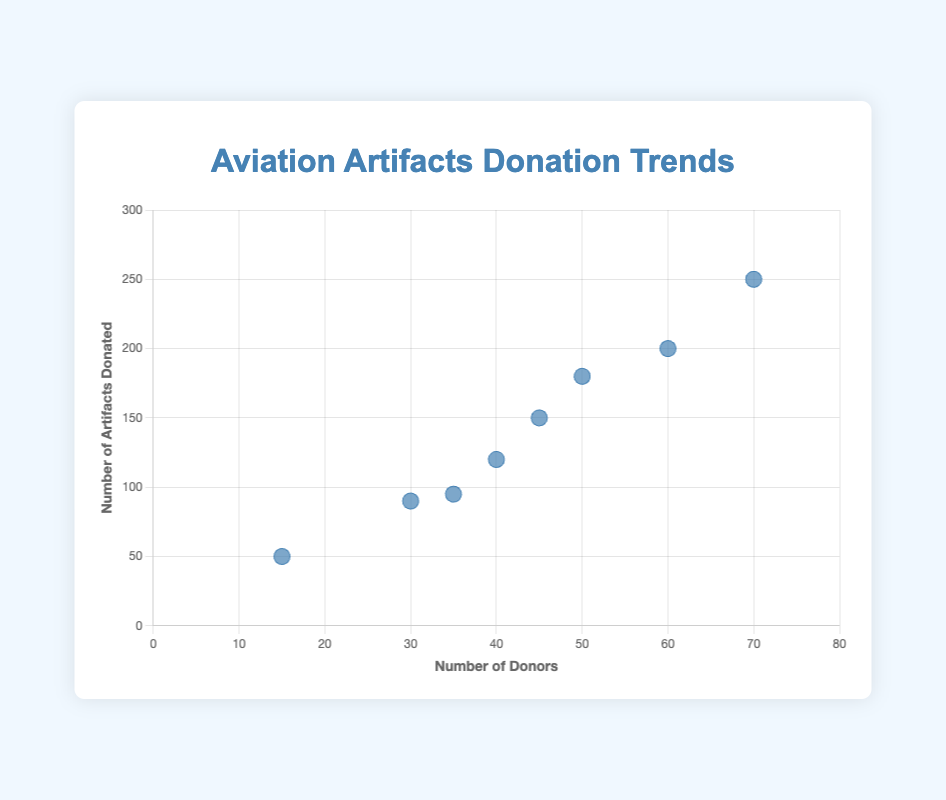How many data points are shown on the scatter plot? The scatter plot represents data for each decade, and there are 8 different decades shown on the plot.
Answer: 8 Which decade has the highest number of aviation artifacts donated? By looking at the y-axis, the 2010s decade has the highest y-value of 250 artifacts donated.
Answer: 2010s Is there a decade where the number of donors exceeds 60? Referring to the x-axis, the 2010s decade is the only one where the number of donors reaches 70, which is greater than 60.
Answer: Yes What is the average number of donors across all decades? Sum all the donors (15+30+40+45+35+50+60+70 = 345) and then divide by the number of decades (345 / 8).
Answer: 43.125 Compare the number of artifacts donated between the 1960s and 1980s. Which decade has more donations? On the y-axis, the 1960s have 120 artifacts donated, while the 1980s have 95 artifacts donated.
Answer: 1960s What is the difference in the number of donors between the 1940s and 2010s? The number of donors in the 1940s is 15, and in the 2010s, it is 70. Their difference is 70 - 15.
Answer: 55 Which decades show a proportional increase in the number of donors and artifacts donated? By observing the trends in the scatter plot, the decades 1950s, 1960s, and 2010s show a proportional increase where both the number of donors and artifacts donated increase significantly.
Answer: 1950s, 1960s, 2010s During which decade does the number of donors show the smallest increase compared to its previous decade? Comparing each increment, the smallest increase is between the 1970s (45 donors) and 1980s (35 donors), showing a decrease rather than an increase.
Answer: 1980s Identify the decade with the smallest number of aviation artifacts donated. Referring to the y-axis, the 1940s have the smallest number of artifacts donated, which is 50.
Answer: 1940s 